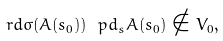Convert formula to latex. <formula><loc_0><loc_0><loc_500><loc_500>\ r d \sigma ( A ( s _ { 0 } ) ) \ p d _ { s } A ( s _ { 0 } ) \notin V _ { 0 } ,</formula> 